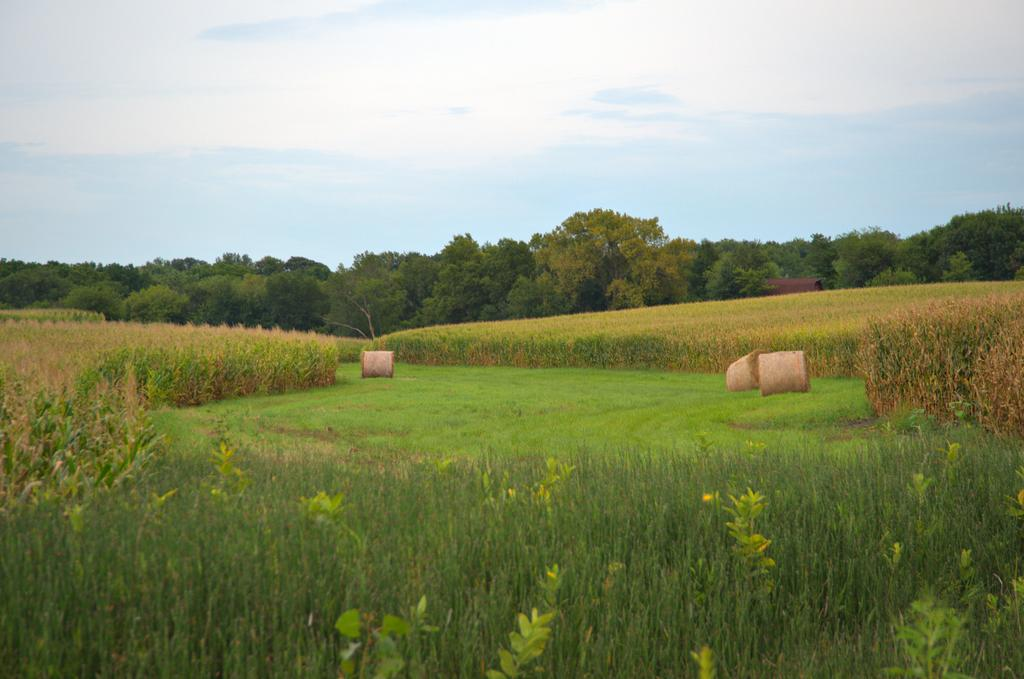What type of vegetation is on the ground in the image? There are plants and grass on the ground in the image. What can be seen in the background of the image? There are trees in the background of the image. What is the color of the sky in the image? The sky is blue in the image. Are there any weather elements visible in the sky? Yes, there are clouds in the sky in the image. How many boys are playing with the lizards in the image? There are no boys or lizards present in the image. Can you describe the robin's nest in the image? There is no robin or nest present in the image. 